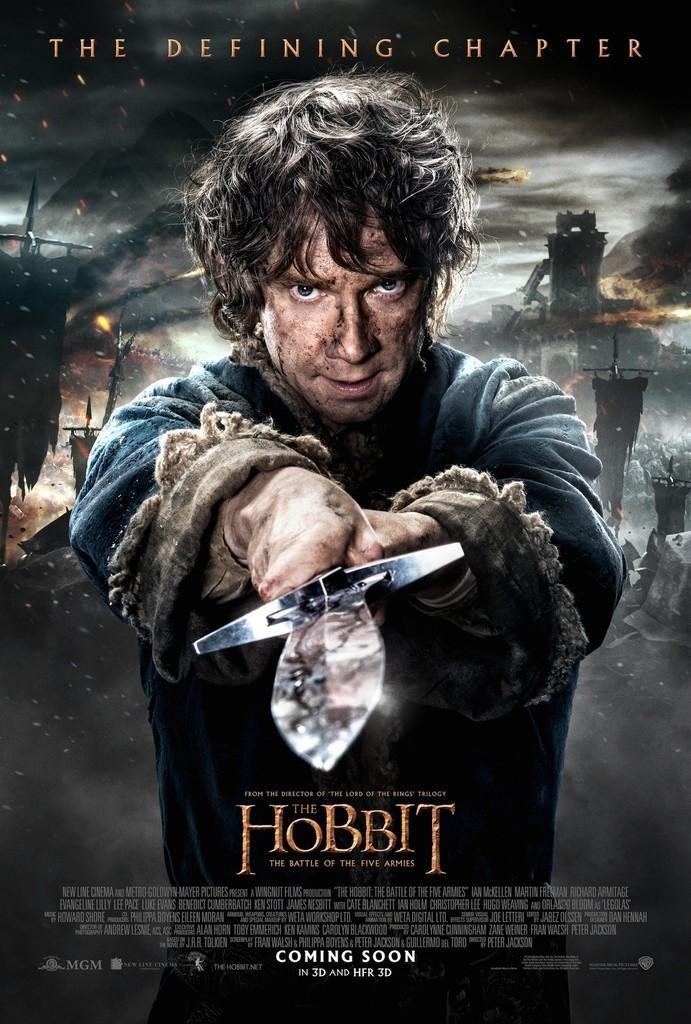How would you summarize this image in a sentence or two? This picture seems to be an animated image. In the center we can see a person holding a sword and standing. In the background we can see the sky and many other objects and we can see the text and numbers on the image. 